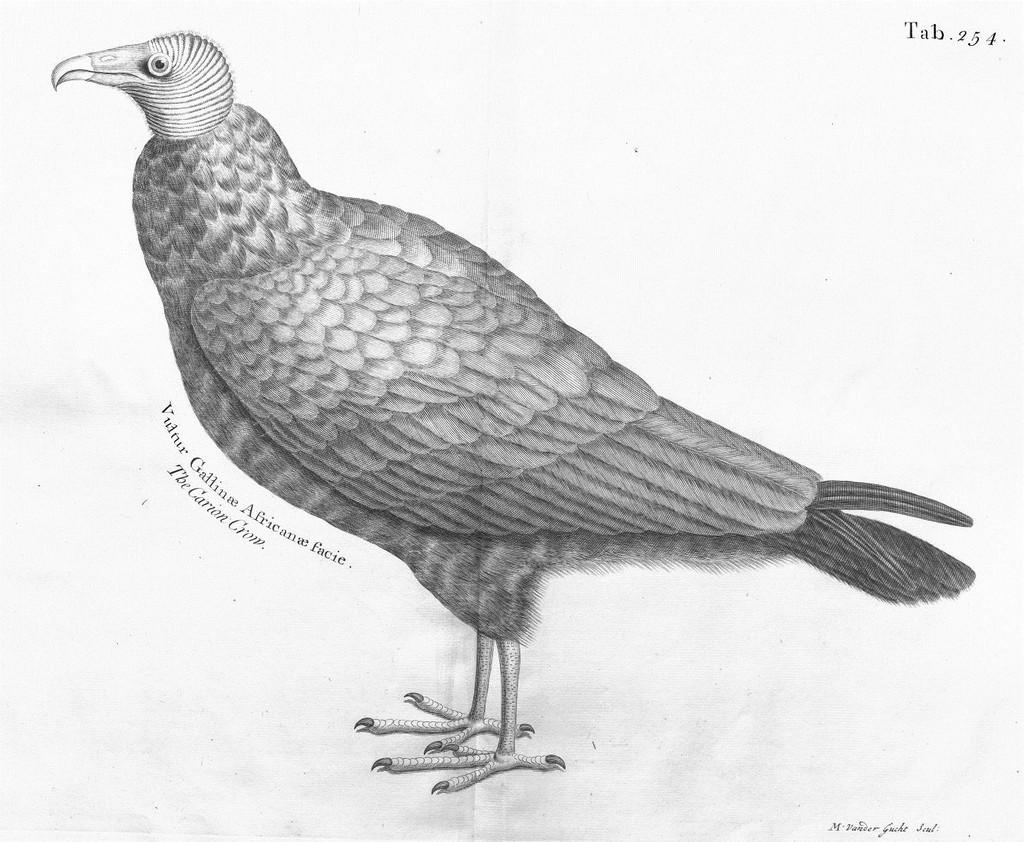What is the main subject of the image? There is a depiction of a bird in the image. Where can text be found in the image? There is text written on the left side of the image and in the top right corner of the image. How many chairs are visible in the image? There are no chairs present in the image. What type of transport is shown in the image? There is no transport depicted in the image; it features a bird and text. 